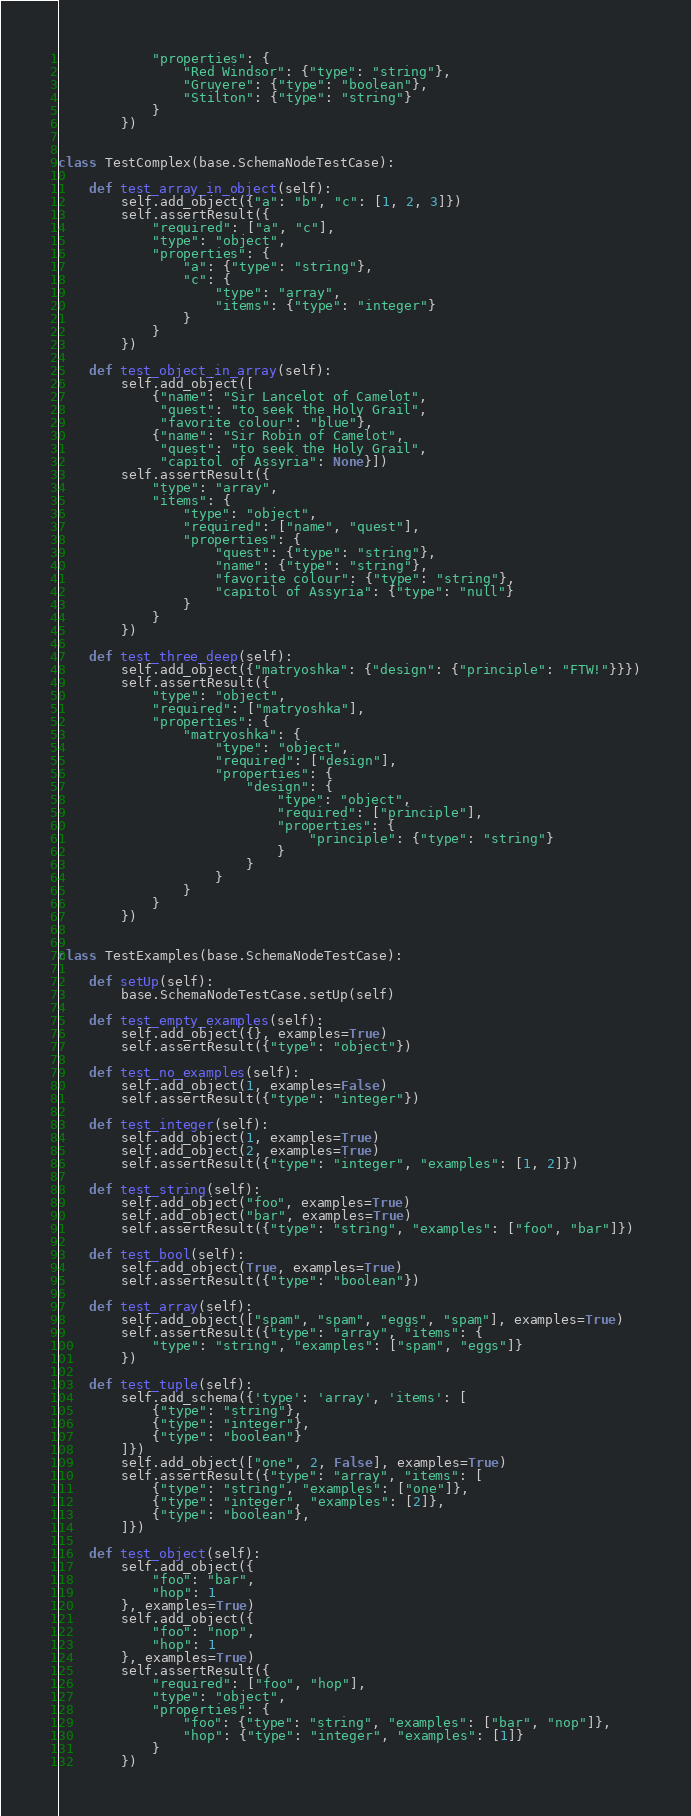<code> <loc_0><loc_0><loc_500><loc_500><_Python_>            "properties": {
                "Red Windsor": {"type": "string"},
                "Gruyere": {"type": "boolean"},
                "Stilton": {"type": "string"}
            }
        })


class TestComplex(base.SchemaNodeTestCase):

    def test_array_in_object(self):
        self.add_object({"a": "b", "c": [1, 2, 3]})
        self.assertResult({
            "required": ["a", "c"],
            "type": "object",
            "properties": {
                "a": {"type": "string"},
                "c": {
                    "type": "array",
                    "items": {"type": "integer"}
                }
            }
        })

    def test_object_in_array(self):
        self.add_object([
            {"name": "Sir Lancelot of Camelot",
             "quest": "to seek the Holy Grail",
             "favorite colour": "blue"},
            {"name": "Sir Robin of Camelot",
             "quest": "to seek the Holy Grail",
             "capitol of Assyria": None}])
        self.assertResult({
            "type": "array",
            "items": {
                "type": "object",
                "required": ["name", "quest"],
                "properties": {
                    "quest": {"type": "string"},
                    "name": {"type": "string"},
                    "favorite colour": {"type": "string"},
                    "capitol of Assyria": {"type": "null"}
                }
            }
        })

    def test_three_deep(self):
        self.add_object({"matryoshka": {"design": {"principle": "FTW!"}}})
        self.assertResult({
            "type": "object",
            "required": ["matryoshka"],
            "properties": {
                "matryoshka": {
                    "type": "object",
                    "required": ["design"],
                    "properties": {
                        "design": {
                            "type": "object",
                            "required": ["principle"],
                            "properties": {
                                "principle": {"type": "string"}
                            }
                        }
                    }
                }
            }
        })


class TestExamples(base.SchemaNodeTestCase):

    def setUp(self):
        base.SchemaNodeTestCase.setUp(self)

    def test_empty_examples(self):
        self.add_object({}, examples=True)
        self.assertResult({"type": "object"})

    def test_no_examples(self):
        self.add_object(1, examples=False)
        self.assertResult({"type": "integer"})

    def test_integer(self):
        self.add_object(1, examples=True)
        self.add_object(2, examples=True)
        self.assertResult({"type": "integer", "examples": [1, 2]})

    def test_string(self):
        self.add_object("foo", examples=True)
        self.add_object("bar", examples=True)
        self.assertResult({"type": "string", "examples": ["foo", "bar"]})

    def test_bool(self):
        self.add_object(True, examples=True)
        self.assertResult({"type": "boolean"})

    def test_array(self):
        self.add_object(["spam", "spam", "eggs", "spam"], examples=True)
        self.assertResult({"type": "array", "items": {
            "type": "string", "examples": ["spam", "eggs"]}
        })

    def test_tuple(self):
        self.add_schema({'type': 'array', 'items': [
            {"type": "string"},
            {"type": "integer"},
            {"type": "boolean"}
        ]})
        self.add_object(["one", 2, False], examples=True)
        self.assertResult({"type": "array", "items": [
            {"type": "string", "examples": ["one"]},
            {"type": "integer", "examples": [2]},
            {"type": "boolean"},
        ]})

    def test_object(self):
        self.add_object({
            "foo": "bar",
            "hop": 1
        }, examples=True)
        self.add_object({
            "foo": "nop",
            "hop": 1
        }, examples=True)
        self.assertResult({
            "required": ["foo", "hop"],
            "type": "object",
            "properties": {
                "foo": {"type": "string", "examples": ["bar", "nop"]},
                "hop": {"type": "integer", "examples": [1]}
            }
        })
</code> 